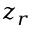<formula> <loc_0><loc_0><loc_500><loc_500>z _ { r }</formula> 